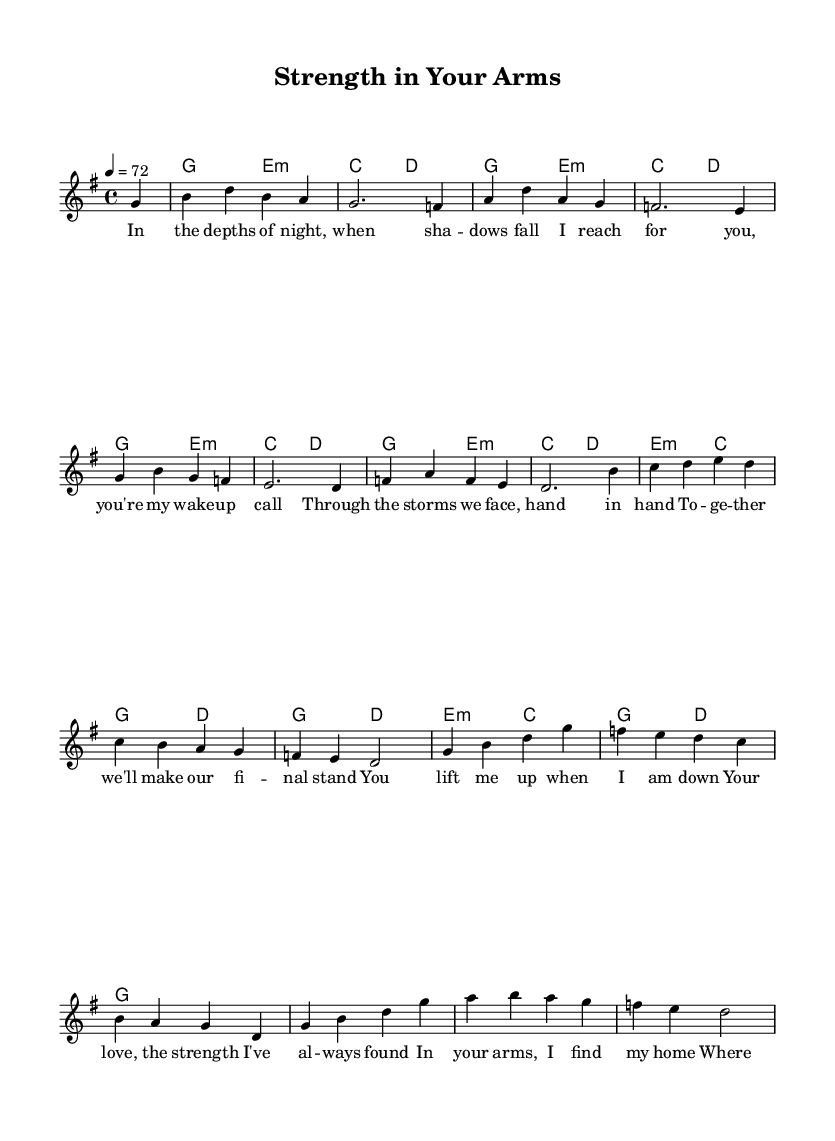What is the key signature of this music? The key signature is indicated at the beginning of the score, where a "g" is noted. This indicates it is in G major, which has one sharp (F#).
Answer: G major What is the time signature of this music? The time signature is found at the start of the score, noted as "4/4". This means there are four beats in each measure, and a quarter note gets one beat.
Answer: 4/4 What is the tempo marking of this piece? The tempo is written at the beginning, with "4 = 72". This indicates that the quarter note (4) is set at a speed of 72 beats per minute.
Answer: 72 How many measures are there in the melody? The melody is divided into distinct measures, which can be counted. Each line represents a set of measures, and counting all shows there are a total of 16 measures.
Answer: 16 Which instrument is primarily featured in this score? The score presents a single staff for the vocals, so it is primarily for voice. The chord names indicate harmonic support rather than primary instrumentation.
Answer: Voice What is the first note of the melody? The melody starts on the first note indicated right after the measure line, which is g in the second octave.
Answer: g How often does the E minor chord appear in the harmonies? By examining the chord symbols throughout the score, the E minor chord appears four times in the harmonic progression.
Answer: 4 